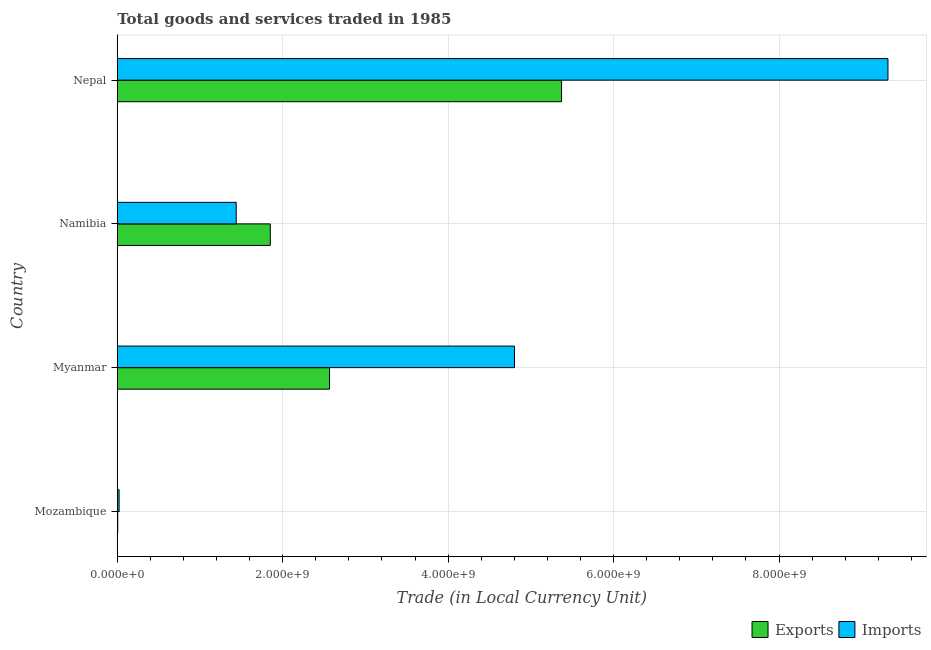How many different coloured bars are there?
Offer a very short reply. 2. How many bars are there on the 3rd tick from the top?
Provide a short and direct response. 2. How many bars are there on the 4th tick from the bottom?
Give a very brief answer. 2. What is the label of the 1st group of bars from the top?
Ensure brevity in your answer.  Nepal. What is the export of goods and services in Myanmar?
Give a very brief answer. 2.57e+09. Across all countries, what is the maximum imports of goods and services?
Give a very brief answer. 9.32e+09. Across all countries, what is the minimum export of goods and services?
Offer a very short reply. 5.50e+06. In which country was the export of goods and services maximum?
Keep it short and to the point. Nepal. In which country was the imports of goods and services minimum?
Provide a succinct answer. Mozambique. What is the total imports of goods and services in the graph?
Provide a succinct answer. 1.56e+1. What is the difference between the export of goods and services in Namibia and that in Nepal?
Offer a terse response. -3.52e+09. What is the difference between the export of goods and services in Namibia and the imports of goods and services in Nepal?
Your answer should be compact. -7.47e+09. What is the average imports of goods and services per country?
Make the answer very short. 3.89e+09. What is the difference between the imports of goods and services and export of goods and services in Myanmar?
Provide a succinct answer. 2.24e+09. What is the ratio of the imports of goods and services in Mozambique to that in Myanmar?
Keep it short and to the point. 0.01. Is the imports of goods and services in Myanmar less than that in Namibia?
Make the answer very short. No. Is the difference between the export of goods and services in Mozambique and Nepal greater than the difference between the imports of goods and services in Mozambique and Nepal?
Ensure brevity in your answer.  Yes. What is the difference between the highest and the second highest export of goods and services?
Your response must be concise. 2.80e+09. What is the difference between the highest and the lowest imports of goods and services?
Ensure brevity in your answer.  9.29e+09. In how many countries, is the export of goods and services greater than the average export of goods and services taken over all countries?
Offer a terse response. 2. What does the 1st bar from the top in Myanmar represents?
Provide a succinct answer. Imports. What does the 1st bar from the bottom in Myanmar represents?
Your answer should be very brief. Exports. How many bars are there?
Provide a succinct answer. 8. Are all the bars in the graph horizontal?
Give a very brief answer. Yes. How many countries are there in the graph?
Ensure brevity in your answer.  4. What is the difference between two consecutive major ticks on the X-axis?
Offer a very short reply. 2.00e+09. How are the legend labels stacked?
Make the answer very short. Horizontal. What is the title of the graph?
Give a very brief answer. Total goods and services traded in 1985. Does "Quality of trade" appear as one of the legend labels in the graph?
Keep it short and to the point. No. What is the label or title of the X-axis?
Your answer should be very brief. Trade (in Local Currency Unit). What is the Trade (in Local Currency Unit) of Exports in Mozambique?
Provide a short and direct response. 5.50e+06. What is the Trade (in Local Currency Unit) in Imports in Mozambique?
Offer a terse response. 2.21e+07. What is the Trade (in Local Currency Unit) in Exports in Myanmar?
Keep it short and to the point. 2.57e+09. What is the Trade (in Local Currency Unit) of Imports in Myanmar?
Offer a very short reply. 4.80e+09. What is the Trade (in Local Currency Unit) of Exports in Namibia?
Your answer should be very brief. 1.85e+09. What is the Trade (in Local Currency Unit) of Imports in Namibia?
Offer a very short reply. 1.44e+09. What is the Trade (in Local Currency Unit) of Exports in Nepal?
Your answer should be compact. 5.37e+09. What is the Trade (in Local Currency Unit) of Imports in Nepal?
Provide a short and direct response. 9.32e+09. Across all countries, what is the maximum Trade (in Local Currency Unit) in Exports?
Ensure brevity in your answer.  5.37e+09. Across all countries, what is the maximum Trade (in Local Currency Unit) in Imports?
Offer a terse response. 9.32e+09. Across all countries, what is the minimum Trade (in Local Currency Unit) of Exports?
Your answer should be compact. 5.50e+06. Across all countries, what is the minimum Trade (in Local Currency Unit) in Imports?
Ensure brevity in your answer.  2.21e+07. What is the total Trade (in Local Currency Unit) in Exports in the graph?
Provide a succinct answer. 9.79e+09. What is the total Trade (in Local Currency Unit) in Imports in the graph?
Your answer should be very brief. 1.56e+1. What is the difference between the Trade (in Local Currency Unit) in Exports in Mozambique and that in Myanmar?
Your answer should be compact. -2.56e+09. What is the difference between the Trade (in Local Currency Unit) of Imports in Mozambique and that in Myanmar?
Your answer should be very brief. -4.78e+09. What is the difference between the Trade (in Local Currency Unit) in Exports in Mozambique and that in Namibia?
Your answer should be very brief. -1.84e+09. What is the difference between the Trade (in Local Currency Unit) in Imports in Mozambique and that in Namibia?
Your answer should be very brief. -1.42e+09. What is the difference between the Trade (in Local Currency Unit) of Exports in Mozambique and that in Nepal?
Your response must be concise. -5.37e+09. What is the difference between the Trade (in Local Currency Unit) of Imports in Mozambique and that in Nepal?
Provide a succinct answer. -9.29e+09. What is the difference between the Trade (in Local Currency Unit) of Exports in Myanmar and that in Namibia?
Your answer should be compact. 7.16e+08. What is the difference between the Trade (in Local Currency Unit) of Imports in Myanmar and that in Namibia?
Your answer should be compact. 3.36e+09. What is the difference between the Trade (in Local Currency Unit) in Exports in Myanmar and that in Nepal?
Provide a succinct answer. -2.80e+09. What is the difference between the Trade (in Local Currency Unit) of Imports in Myanmar and that in Nepal?
Provide a succinct answer. -4.52e+09. What is the difference between the Trade (in Local Currency Unit) in Exports in Namibia and that in Nepal?
Offer a very short reply. -3.52e+09. What is the difference between the Trade (in Local Currency Unit) in Imports in Namibia and that in Nepal?
Provide a short and direct response. -7.88e+09. What is the difference between the Trade (in Local Currency Unit) of Exports in Mozambique and the Trade (in Local Currency Unit) of Imports in Myanmar?
Your response must be concise. -4.80e+09. What is the difference between the Trade (in Local Currency Unit) of Exports in Mozambique and the Trade (in Local Currency Unit) of Imports in Namibia?
Give a very brief answer. -1.43e+09. What is the difference between the Trade (in Local Currency Unit) in Exports in Mozambique and the Trade (in Local Currency Unit) in Imports in Nepal?
Your answer should be compact. -9.31e+09. What is the difference between the Trade (in Local Currency Unit) in Exports in Myanmar and the Trade (in Local Currency Unit) in Imports in Namibia?
Make the answer very short. 1.13e+09. What is the difference between the Trade (in Local Currency Unit) in Exports in Myanmar and the Trade (in Local Currency Unit) in Imports in Nepal?
Your answer should be compact. -6.75e+09. What is the difference between the Trade (in Local Currency Unit) in Exports in Namibia and the Trade (in Local Currency Unit) in Imports in Nepal?
Your response must be concise. -7.47e+09. What is the average Trade (in Local Currency Unit) of Exports per country?
Offer a very short reply. 2.45e+09. What is the average Trade (in Local Currency Unit) in Imports per country?
Your answer should be compact. 3.89e+09. What is the difference between the Trade (in Local Currency Unit) in Exports and Trade (in Local Currency Unit) in Imports in Mozambique?
Offer a very short reply. -1.66e+07. What is the difference between the Trade (in Local Currency Unit) in Exports and Trade (in Local Currency Unit) in Imports in Myanmar?
Your response must be concise. -2.24e+09. What is the difference between the Trade (in Local Currency Unit) in Exports and Trade (in Local Currency Unit) in Imports in Namibia?
Offer a very short reply. 4.12e+08. What is the difference between the Trade (in Local Currency Unit) in Exports and Trade (in Local Currency Unit) in Imports in Nepal?
Give a very brief answer. -3.95e+09. What is the ratio of the Trade (in Local Currency Unit) in Exports in Mozambique to that in Myanmar?
Make the answer very short. 0. What is the ratio of the Trade (in Local Currency Unit) of Imports in Mozambique to that in Myanmar?
Make the answer very short. 0. What is the ratio of the Trade (in Local Currency Unit) in Exports in Mozambique to that in Namibia?
Ensure brevity in your answer.  0. What is the ratio of the Trade (in Local Currency Unit) in Imports in Mozambique to that in Namibia?
Make the answer very short. 0.02. What is the ratio of the Trade (in Local Currency Unit) in Imports in Mozambique to that in Nepal?
Give a very brief answer. 0. What is the ratio of the Trade (in Local Currency Unit) of Exports in Myanmar to that in Namibia?
Provide a succinct answer. 1.39. What is the ratio of the Trade (in Local Currency Unit) of Imports in Myanmar to that in Namibia?
Provide a short and direct response. 3.34. What is the ratio of the Trade (in Local Currency Unit) in Exports in Myanmar to that in Nepal?
Offer a very short reply. 0.48. What is the ratio of the Trade (in Local Currency Unit) of Imports in Myanmar to that in Nepal?
Give a very brief answer. 0.52. What is the ratio of the Trade (in Local Currency Unit) of Exports in Namibia to that in Nepal?
Offer a very short reply. 0.34. What is the ratio of the Trade (in Local Currency Unit) in Imports in Namibia to that in Nepal?
Ensure brevity in your answer.  0.15. What is the difference between the highest and the second highest Trade (in Local Currency Unit) of Exports?
Make the answer very short. 2.80e+09. What is the difference between the highest and the second highest Trade (in Local Currency Unit) of Imports?
Keep it short and to the point. 4.52e+09. What is the difference between the highest and the lowest Trade (in Local Currency Unit) of Exports?
Offer a very short reply. 5.37e+09. What is the difference between the highest and the lowest Trade (in Local Currency Unit) of Imports?
Ensure brevity in your answer.  9.29e+09. 